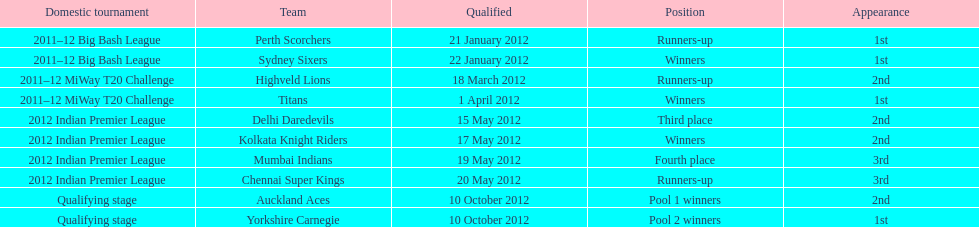Which game came in first in the 2012 indian premier league? Kolkata Knight Riders. 